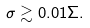<formula> <loc_0><loc_0><loc_500><loc_500>\sigma \gtrsim 0 . 0 1 \Sigma .</formula> 